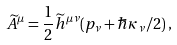<formula> <loc_0><loc_0><loc_500><loc_500>\widetilde { A } ^ { \mu } = \frac { 1 } { 2 } \widetilde { h } ^ { \mu \nu } ( p _ { \nu } + \hbar { \kappa } _ { \nu } / 2 ) \, ,</formula> 